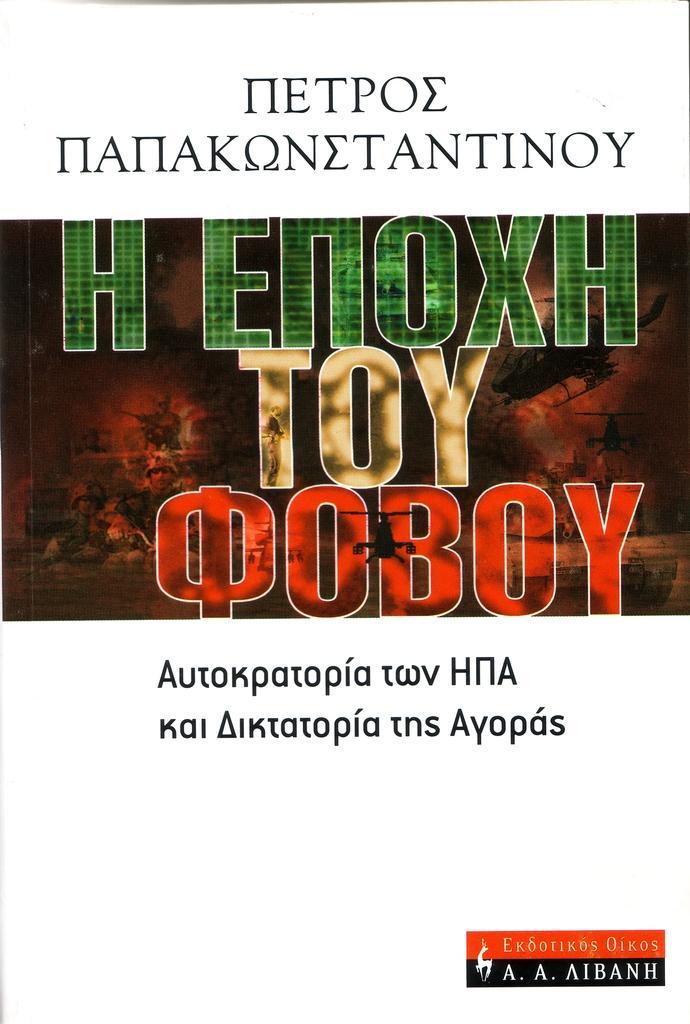Please provide a concise description of this image. In this image I can see a paper and I can see something written on the paper with black, green and red color. 